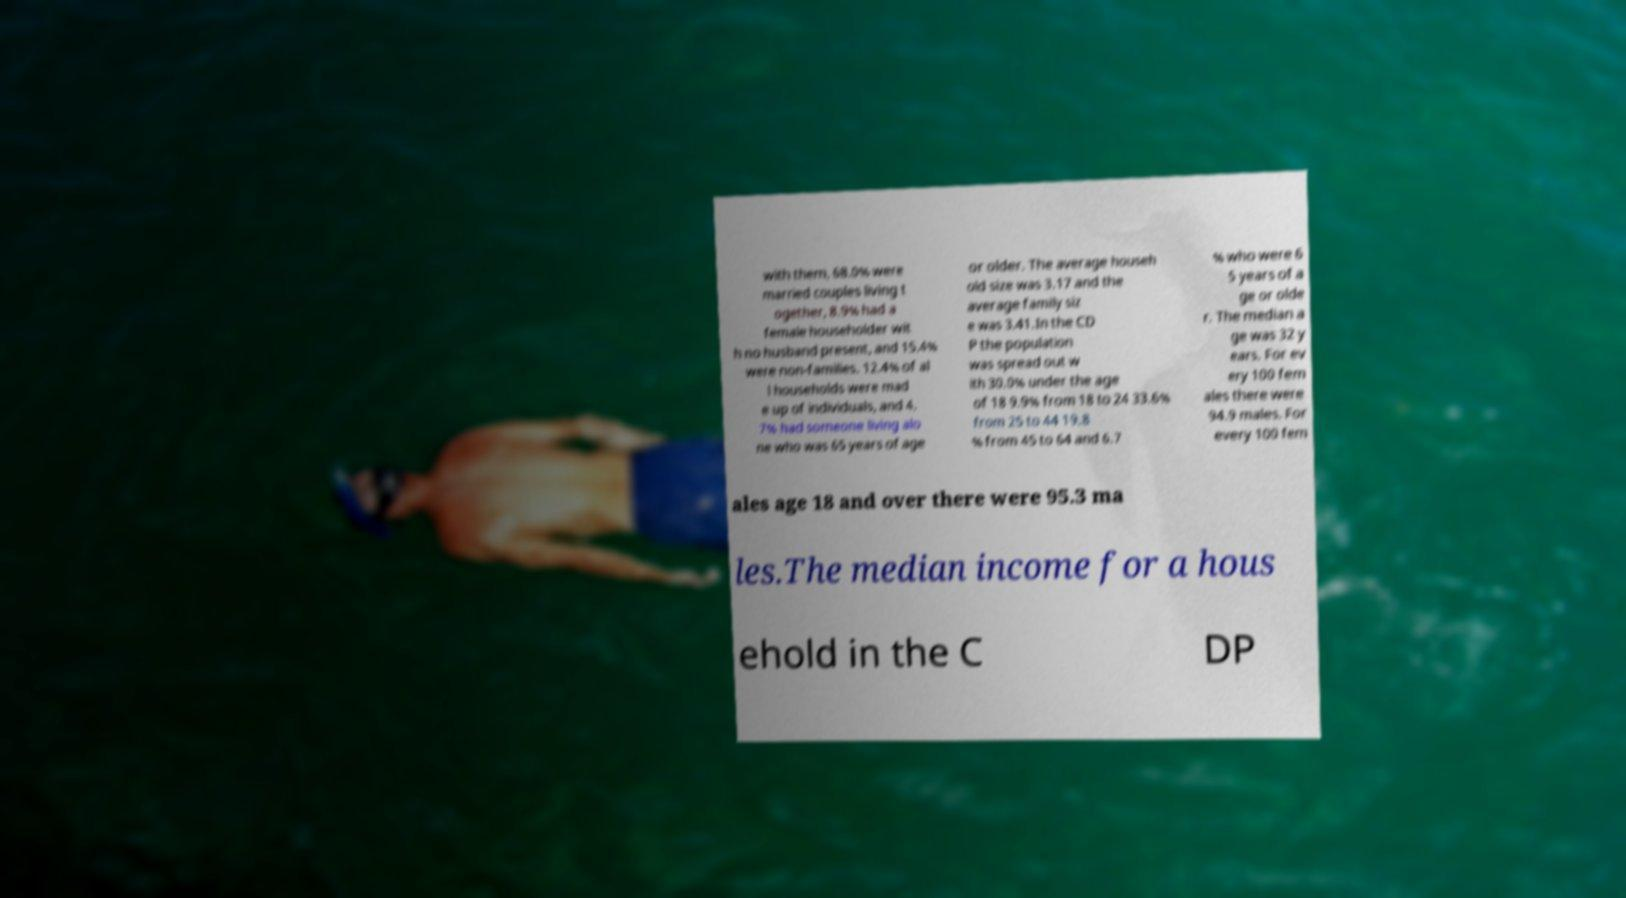Please identify and transcribe the text found in this image. with them, 68.0% were married couples living t ogether, 8.9% had a female householder wit h no husband present, and 15.4% were non-families. 12.4% of al l households were mad e up of individuals, and 4. 7% had someone living alo ne who was 65 years of age or older. The average househ old size was 3.17 and the average family siz e was 3.41.In the CD P the population was spread out w ith 30.0% under the age of 18 9.9% from 18 to 24 33.6% from 25 to 44 19.8 % from 45 to 64 and 6.7 % who were 6 5 years of a ge or olde r. The median a ge was 32 y ears. For ev ery 100 fem ales there were 94.9 males. For every 100 fem ales age 18 and over there were 95.3 ma les.The median income for a hous ehold in the C DP 